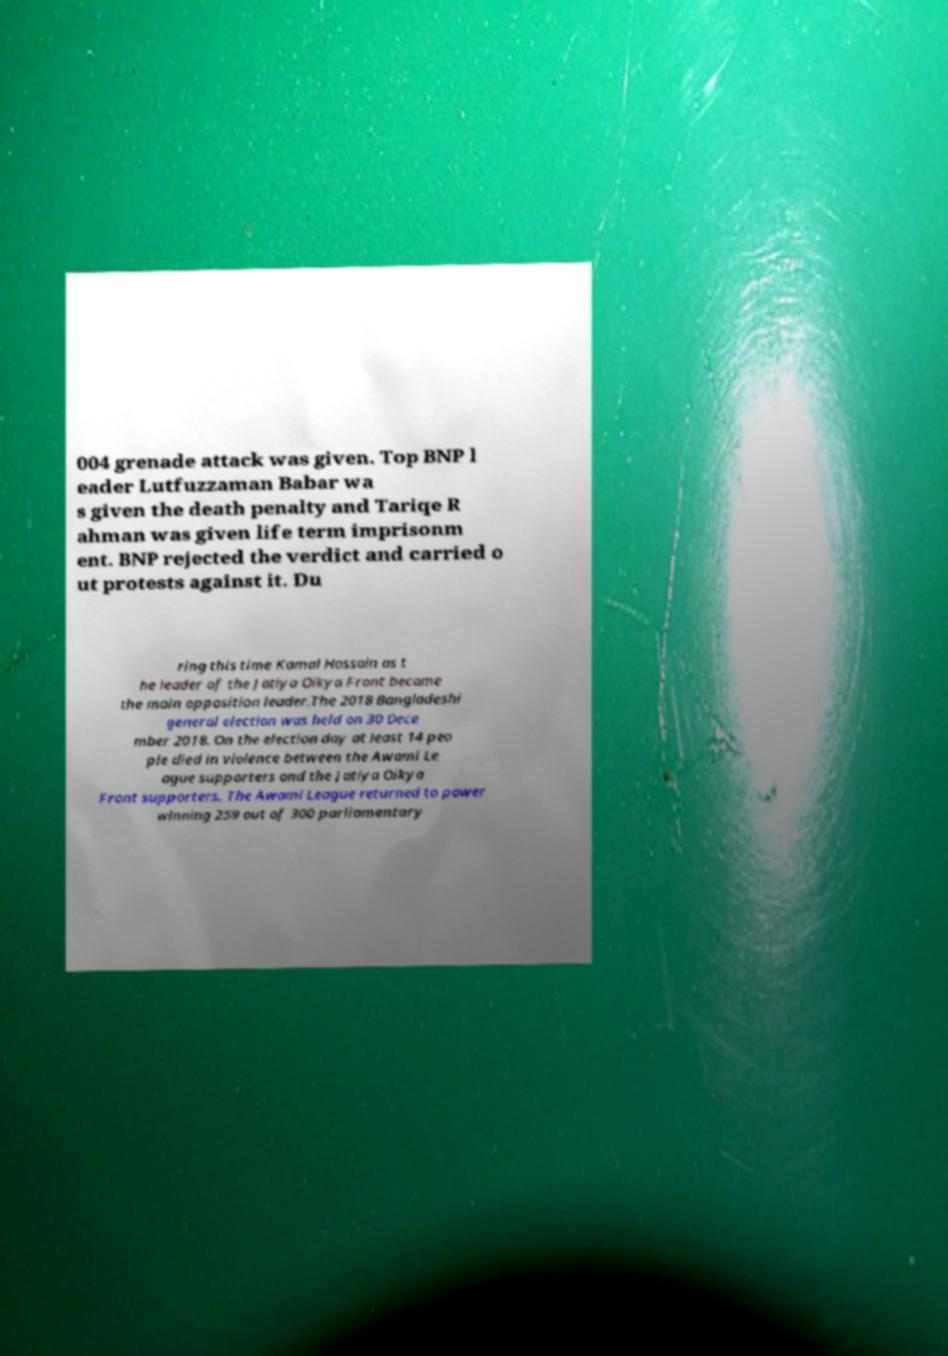What messages or text are displayed in this image? I need them in a readable, typed format. 004 grenade attack was given. Top BNP l eader Lutfuzzaman Babar wa s given the death penalty and Tariqe R ahman was given life term imprisonm ent. BNP rejected the verdict and carried o ut protests against it. Du ring this time Kamal Hossain as t he leader of the Jatiya Oikya Front became the main opposition leader.The 2018 Bangladeshi general election was held on 30 Dece mber 2018. On the election day at least 14 peo ple died in violence between the Awami Le ague supporters and the Jatiya Oikya Front supporters. The Awami League returned to power winning 259 out of 300 parliamentary 